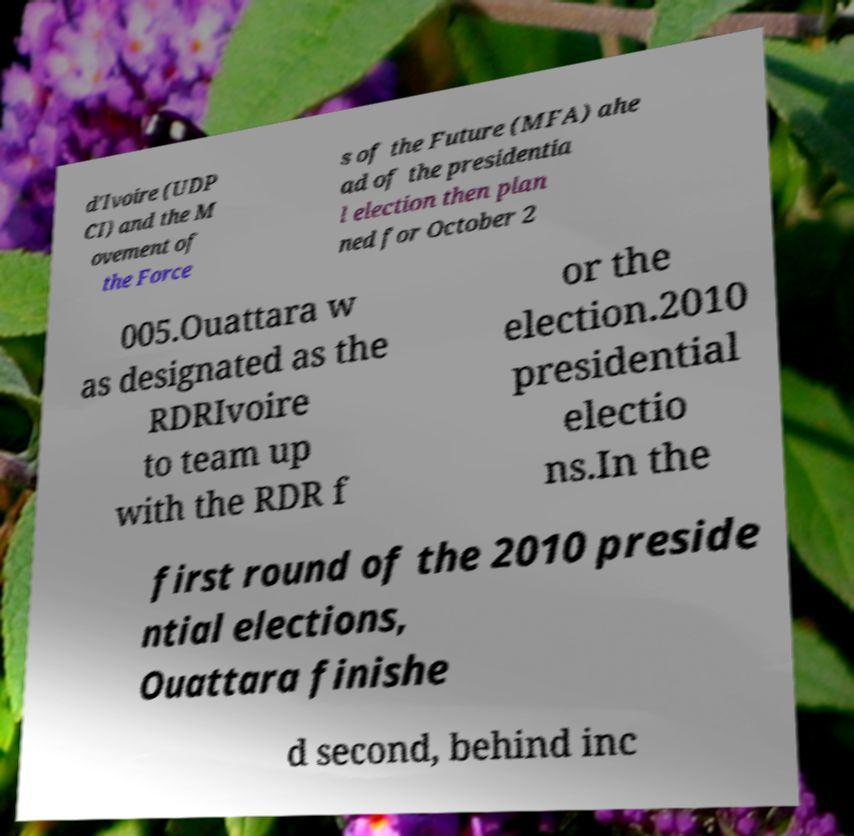Can you accurately transcribe the text from the provided image for me? d'Ivoire (UDP CI) and the M ovement of the Force s of the Future (MFA) ahe ad of the presidentia l election then plan ned for October 2 005.Ouattara w as designated as the RDRIvoire to team up with the RDR f or the election.2010 presidential electio ns.In the first round of the 2010 preside ntial elections, Ouattara finishe d second, behind inc 